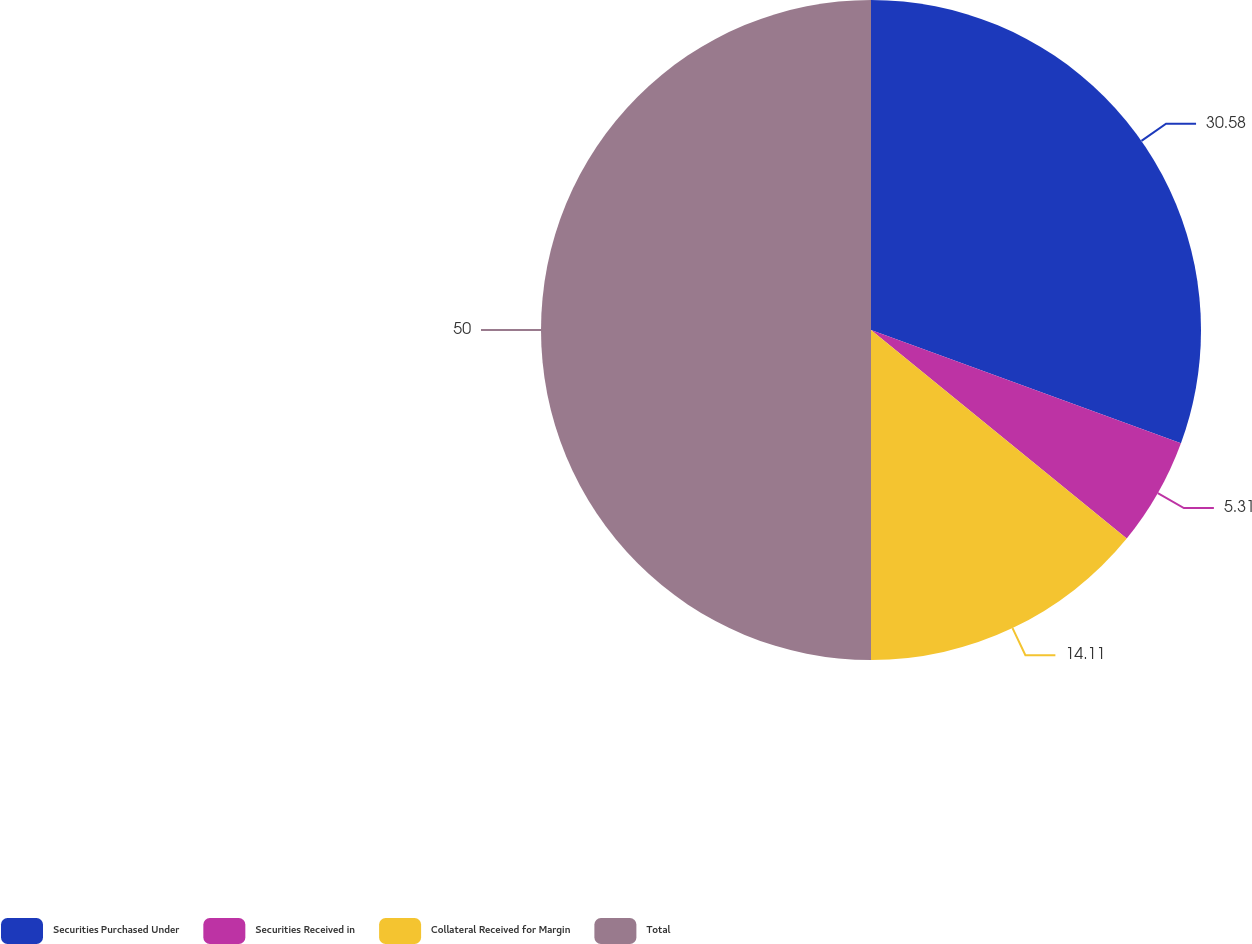<chart> <loc_0><loc_0><loc_500><loc_500><pie_chart><fcel>Securities Purchased Under<fcel>Securities Received in<fcel>Collateral Received for Margin<fcel>Total<nl><fcel>30.58%<fcel>5.31%<fcel>14.11%<fcel>50.0%<nl></chart> 